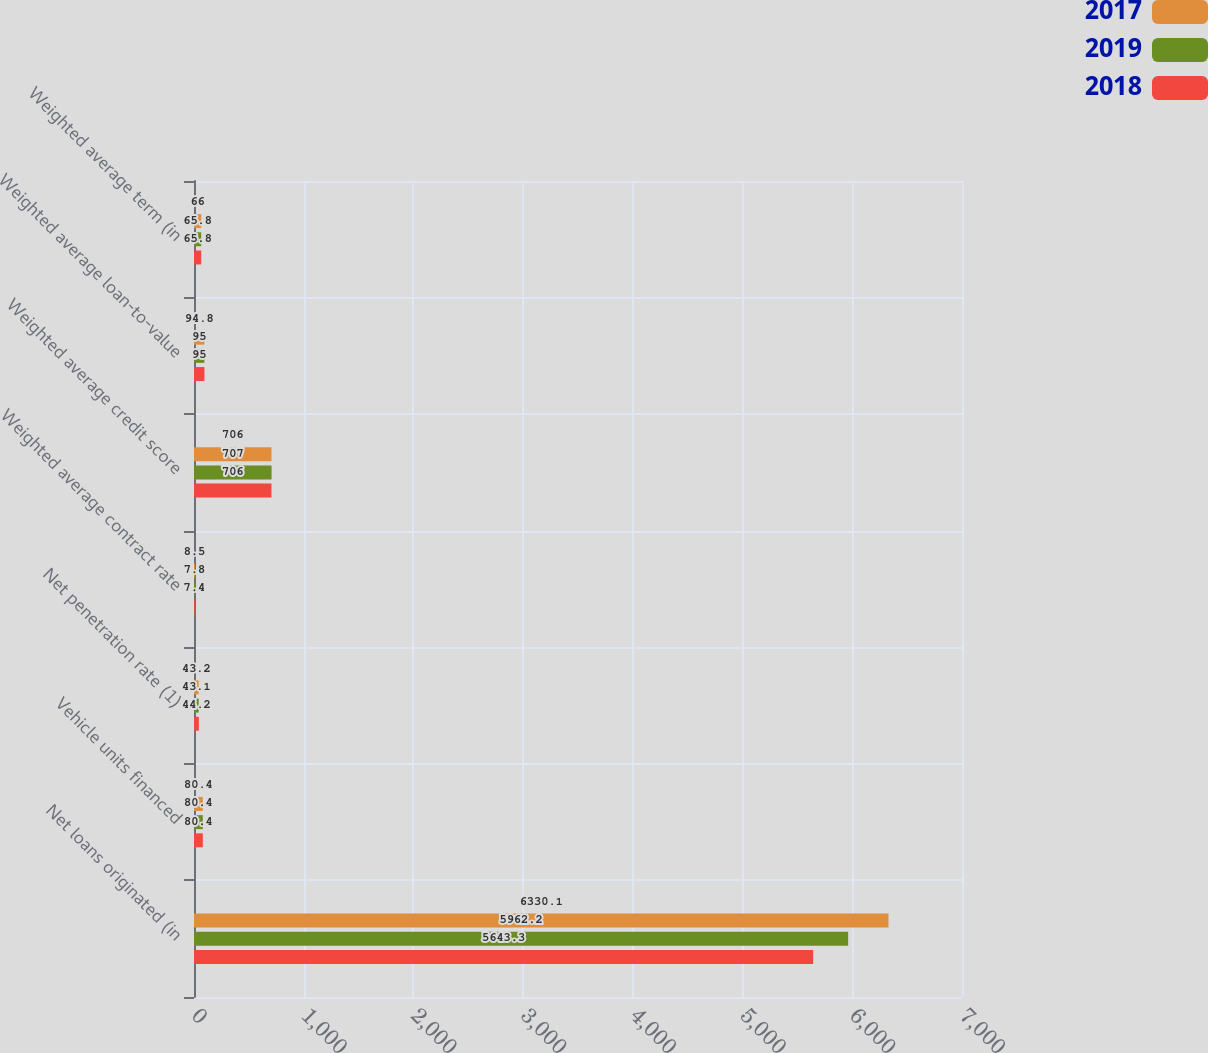<chart> <loc_0><loc_0><loc_500><loc_500><stacked_bar_chart><ecel><fcel>Net loans originated (in<fcel>Vehicle units financed<fcel>Net penetration rate (1)<fcel>Weighted average contract rate<fcel>Weighted average credit score<fcel>Weighted average loan-to-value<fcel>Weighted average term (in<nl><fcel>2017<fcel>6330.1<fcel>80.4<fcel>43.2<fcel>8.5<fcel>706<fcel>94.8<fcel>66<nl><fcel>2019<fcel>5962.2<fcel>80.4<fcel>43.1<fcel>7.8<fcel>707<fcel>95<fcel>65.8<nl><fcel>2018<fcel>5643.3<fcel>80.4<fcel>44.2<fcel>7.4<fcel>706<fcel>95<fcel>65.8<nl></chart> 